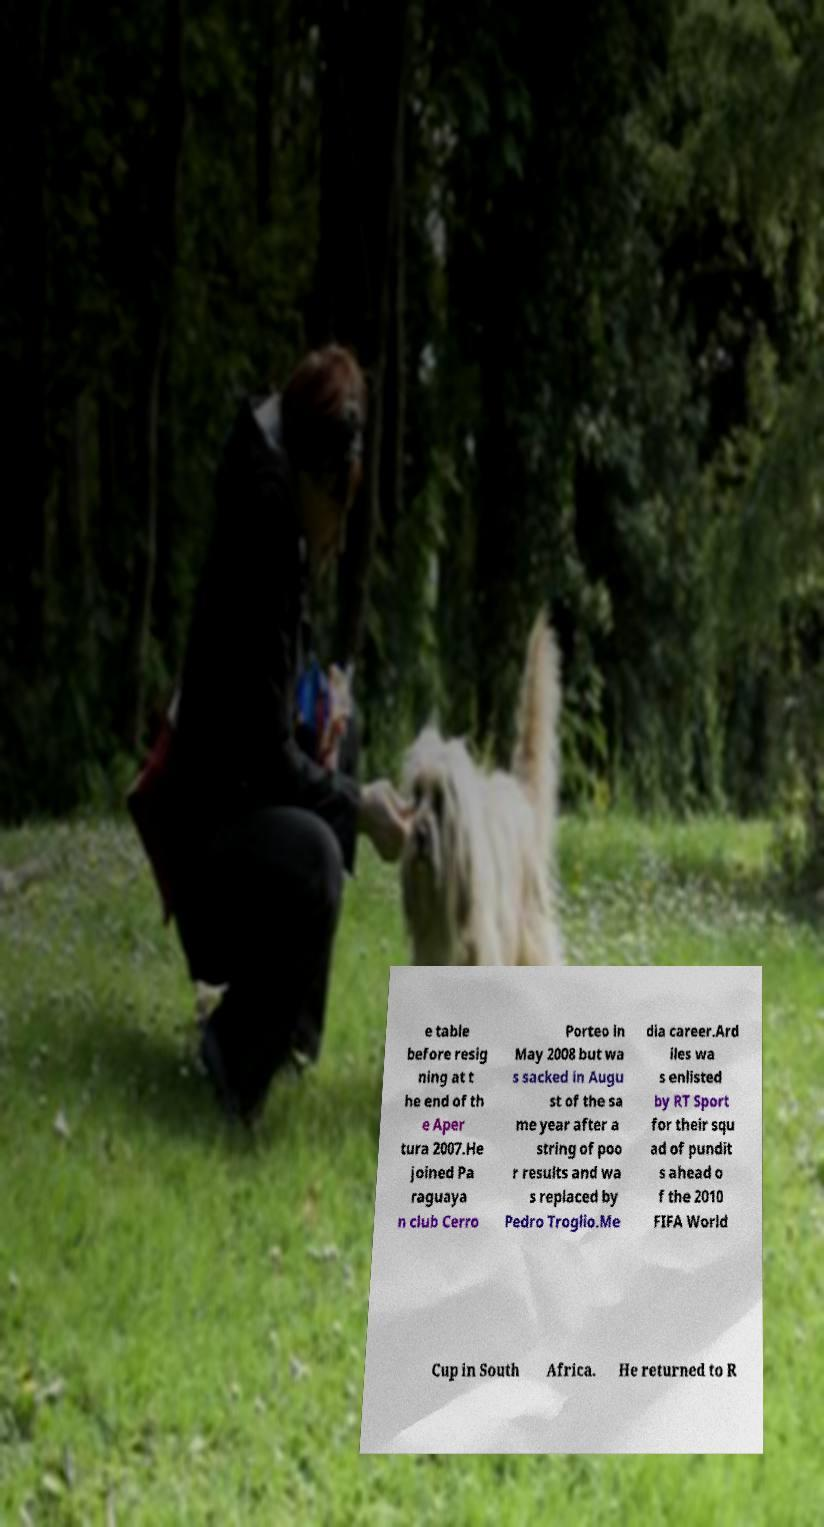There's text embedded in this image that I need extracted. Can you transcribe it verbatim? e table before resig ning at t he end of th e Aper tura 2007.He joined Pa raguaya n club Cerro Porteo in May 2008 but wa s sacked in Augu st of the sa me year after a string of poo r results and wa s replaced by Pedro Troglio.Me dia career.Ard iles wa s enlisted by RT Sport for their squ ad of pundit s ahead o f the 2010 FIFA World Cup in South Africa. He returned to R 